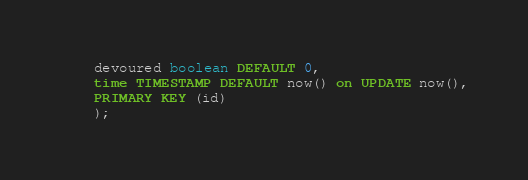Convert code to text. <code><loc_0><loc_0><loc_500><loc_500><_SQL_>	devoured boolean DEFAULT 0,
	time TIMESTAMP DEFAULT now() on UPDATE now(),
	PRIMARY KEY (id) 
    );</code> 